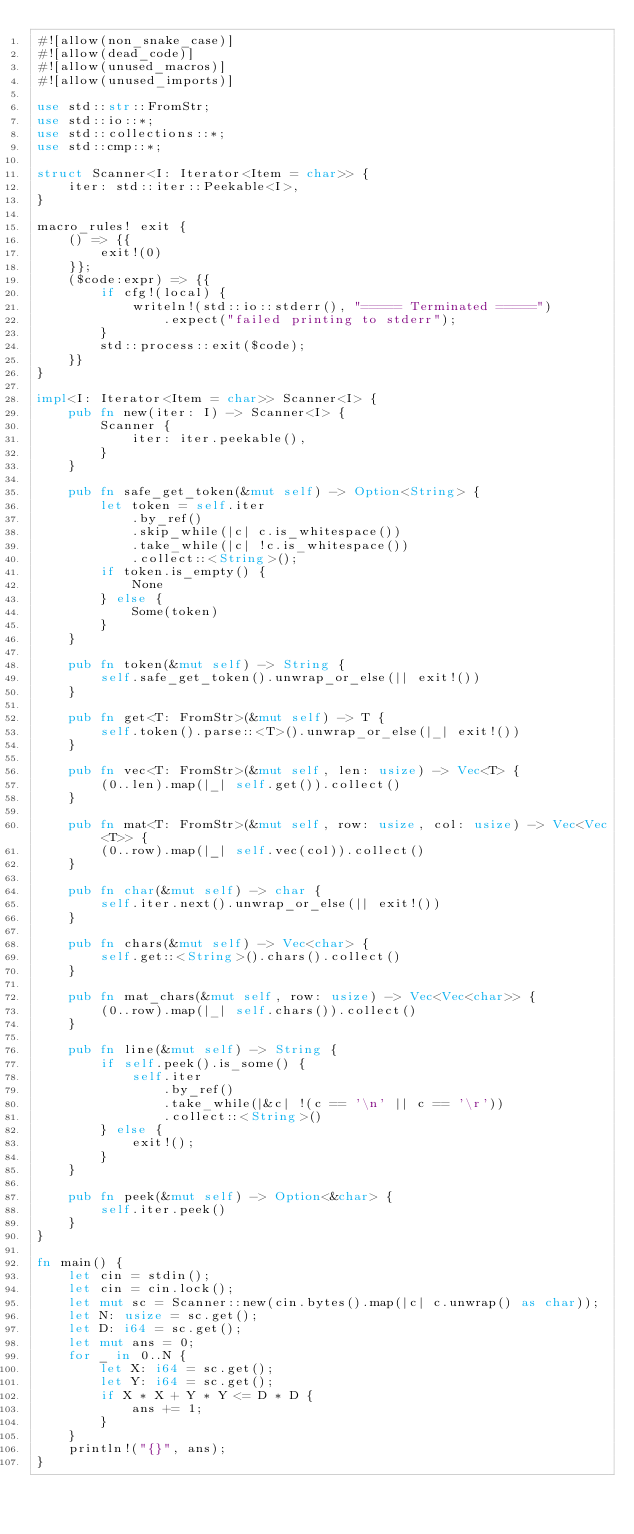<code> <loc_0><loc_0><loc_500><loc_500><_Rust_>#![allow(non_snake_case)]
#![allow(dead_code)]
#![allow(unused_macros)]
#![allow(unused_imports)]

use std::str::FromStr;
use std::io::*;
use std::collections::*;
use std::cmp::*;

struct Scanner<I: Iterator<Item = char>> {
    iter: std::iter::Peekable<I>,
}

macro_rules! exit {
    () => {{
        exit!(0)
    }};
    ($code:expr) => {{
        if cfg!(local) {
            writeln!(std::io::stderr(), "===== Terminated =====")
                .expect("failed printing to stderr");
        }
        std::process::exit($code);
    }}
}

impl<I: Iterator<Item = char>> Scanner<I> {
    pub fn new(iter: I) -> Scanner<I> {
        Scanner {
            iter: iter.peekable(),
        }
    }

    pub fn safe_get_token(&mut self) -> Option<String> {
        let token = self.iter
            .by_ref()
            .skip_while(|c| c.is_whitespace())
            .take_while(|c| !c.is_whitespace())
            .collect::<String>();
        if token.is_empty() {
            None
        } else {
            Some(token)
        }
    }

    pub fn token(&mut self) -> String {
        self.safe_get_token().unwrap_or_else(|| exit!())
    }

    pub fn get<T: FromStr>(&mut self) -> T {
        self.token().parse::<T>().unwrap_or_else(|_| exit!())
    }

    pub fn vec<T: FromStr>(&mut self, len: usize) -> Vec<T> {
        (0..len).map(|_| self.get()).collect()
    }

    pub fn mat<T: FromStr>(&mut self, row: usize, col: usize) -> Vec<Vec<T>> {
        (0..row).map(|_| self.vec(col)).collect()
    }

    pub fn char(&mut self) -> char {
        self.iter.next().unwrap_or_else(|| exit!())
    }

    pub fn chars(&mut self) -> Vec<char> {
        self.get::<String>().chars().collect()
    }

    pub fn mat_chars(&mut self, row: usize) -> Vec<Vec<char>> {
        (0..row).map(|_| self.chars()).collect()
    }

    pub fn line(&mut self) -> String {
        if self.peek().is_some() {
            self.iter
                .by_ref()
                .take_while(|&c| !(c == '\n' || c == '\r'))
                .collect::<String>()
        } else {
            exit!();
        }
    }

    pub fn peek(&mut self) -> Option<&char> {
        self.iter.peek()
    }
}

fn main() {
    let cin = stdin();
    let cin = cin.lock();
    let mut sc = Scanner::new(cin.bytes().map(|c| c.unwrap() as char));
    let N: usize = sc.get();
    let D: i64 = sc.get();
    let mut ans = 0;
    for _ in 0..N {
        let X: i64 = sc.get();
        let Y: i64 = sc.get();
        if X * X + Y * Y <= D * D {
            ans += 1;
        }
    }
    println!("{}", ans);
}
</code> 